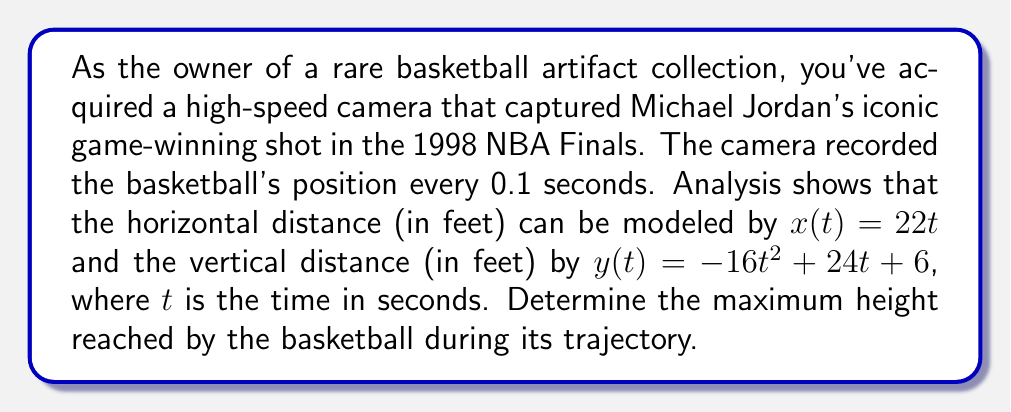Show me your answer to this math problem. To find the maximum height of the basketball's trajectory, we need to analyze the vertical component of the parametric equations, which is given by $y(t) = -16t^2 + 24t + 6$.

1) The maximum height occurs when the vertical velocity is zero. We can find this by taking the derivative of $y(t)$ with respect to $t$ and setting it equal to zero:

   $\frac{dy}{dt} = -32t + 24$

2) Set this equal to zero and solve for $t$:
   
   $-32t + 24 = 0$
   $-32t = -24$
   $t = \frac{3}{4} = 0.75$ seconds

3) Now that we know the time at which the maximum height occurs, we can substitute this value of $t$ back into the original equation for $y(t)$:

   $y(0.75) = -16(0.75)^2 + 24(0.75) + 6$
   
   $= -16(0.5625) + 18 + 6$
   
   $= -9 + 18 + 6$
   
   $= 15$ feet

Therefore, the maximum height reached by the basketball is 15 feet.
Answer: The maximum height reached by the basketball during its trajectory is 15 feet. 